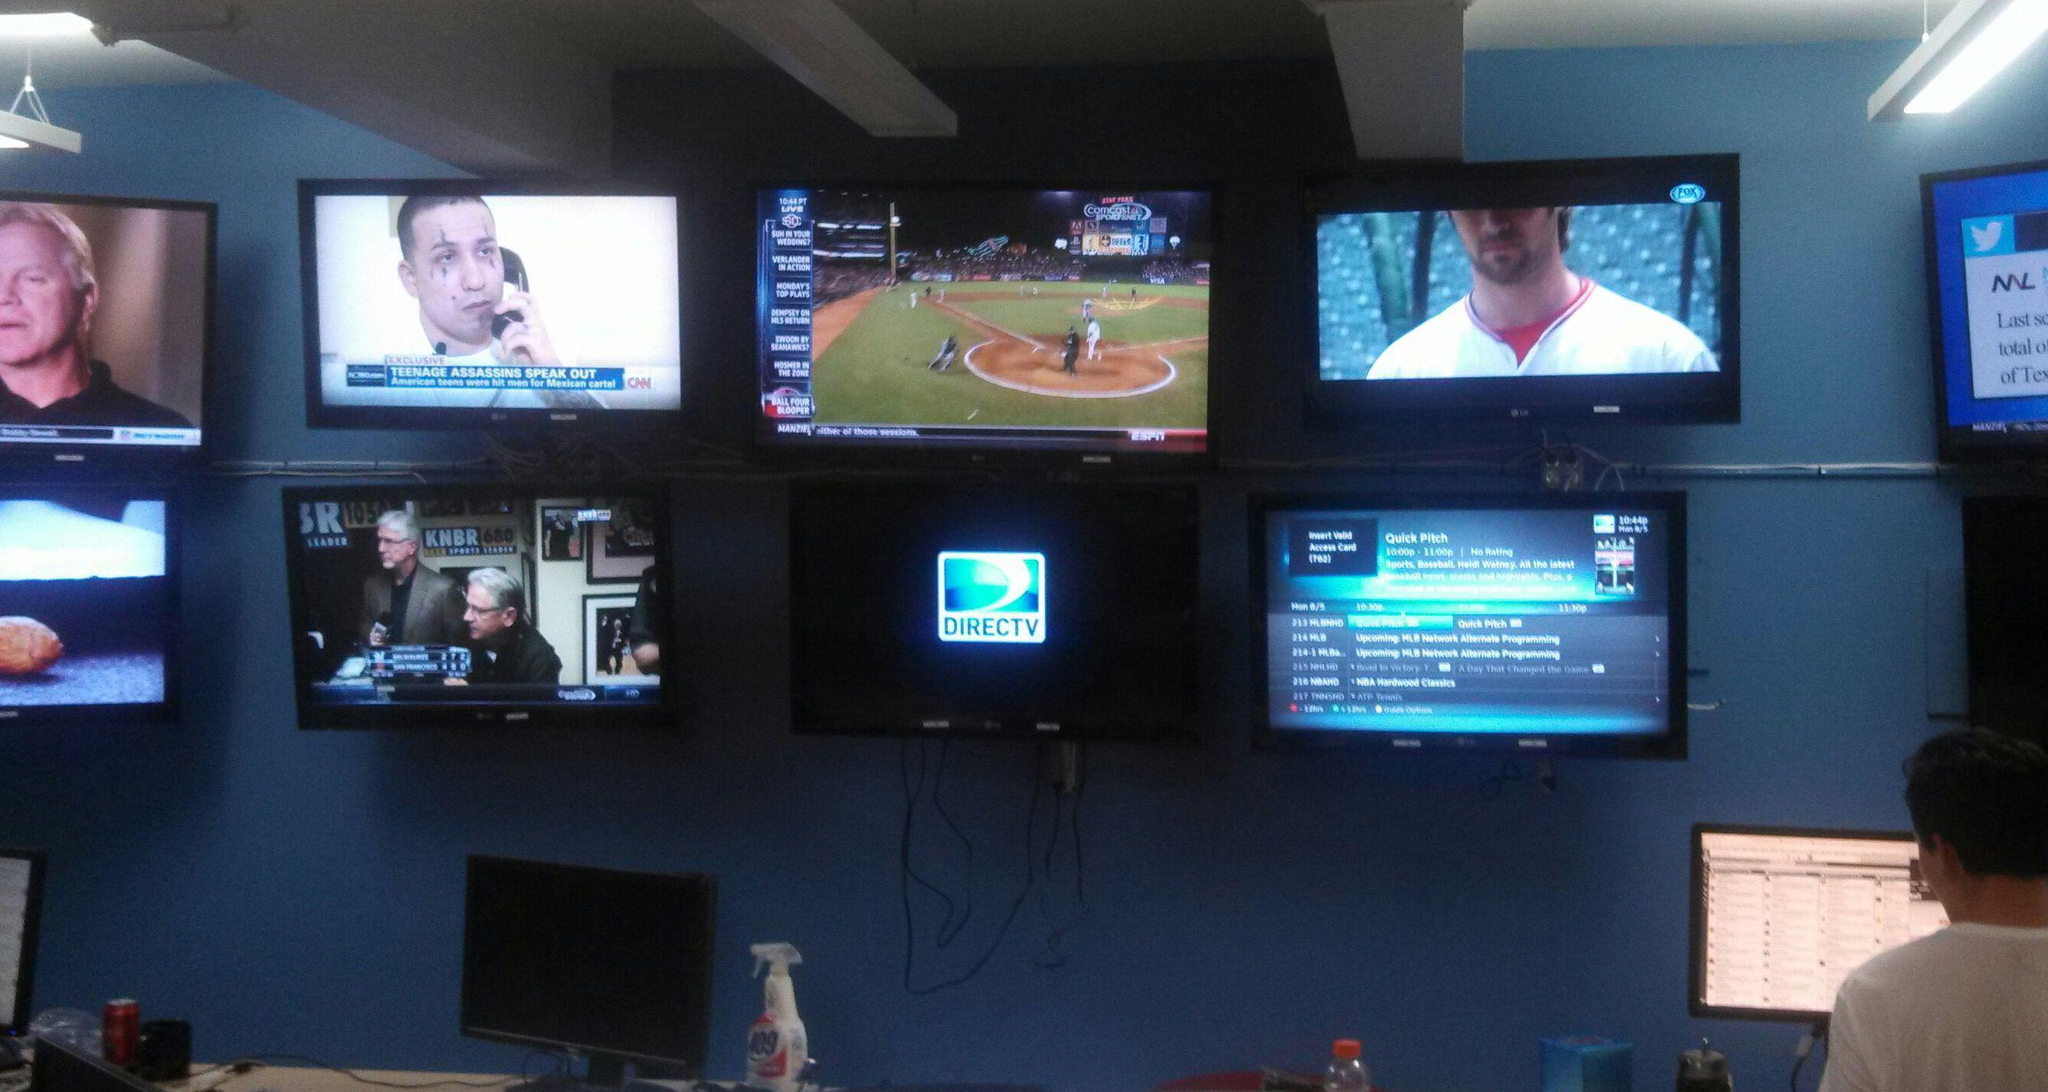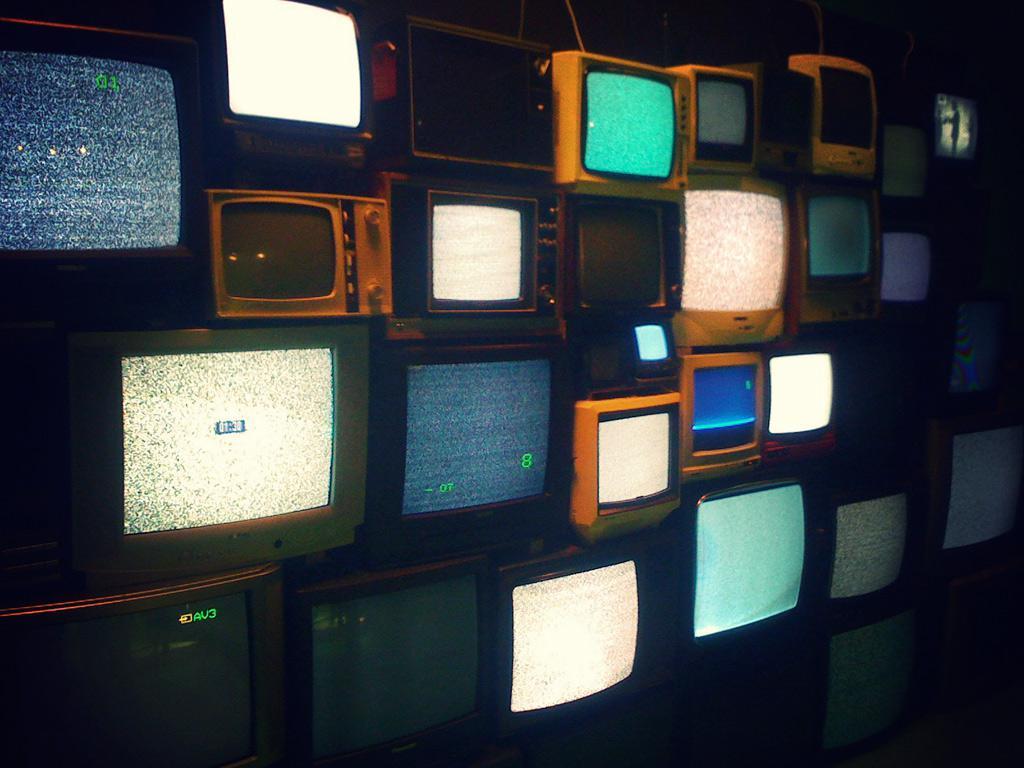The first image is the image on the left, the second image is the image on the right. For the images shown, is this caption "One of the images shows a group of at least ten vintage television sets." true? Answer yes or no. Yes. The first image is the image on the left, the second image is the image on the right. For the images shown, is this caption "An image shows at least four stacked rows that include non-flatscreen type TVs." true? Answer yes or no. Yes. 